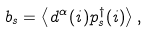Convert formula to latex. <formula><loc_0><loc_0><loc_500><loc_500>b _ { s } = \left \langle d ^ { \alpha } ( i ) p _ { s } ^ { \dagger } ( i ) \right \rangle ,</formula> 